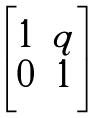Convert formula to latex. <formula><loc_0><loc_0><loc_500><loc_500>\begin{bmatrix} 1 & q \\ 0 & 1 \end{bmatrix}</formula> 